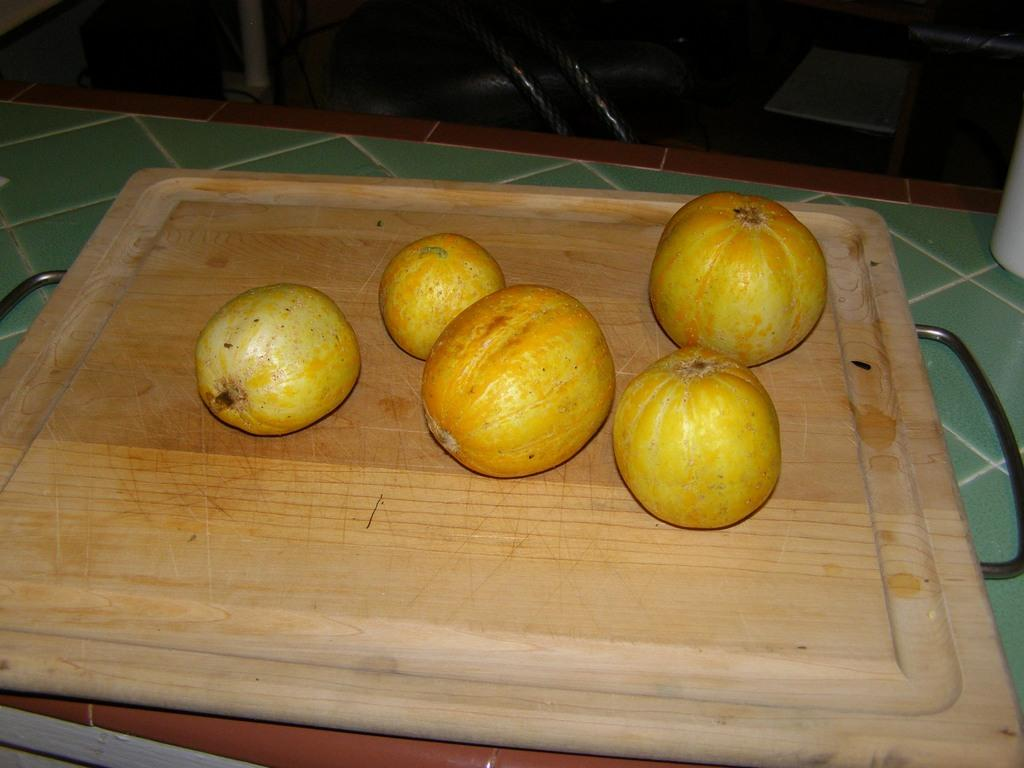What is the main piece of furniture in the image? There is a table in the image. What is placed on the table? There is a chopping board on the table. What is on the chopping board? There are vegetables on the chopping board. How many eyes can be seen on the vegetables in the image? Vegetables do not have eyes, so there are no eyes visible on the vegetables in the image. 